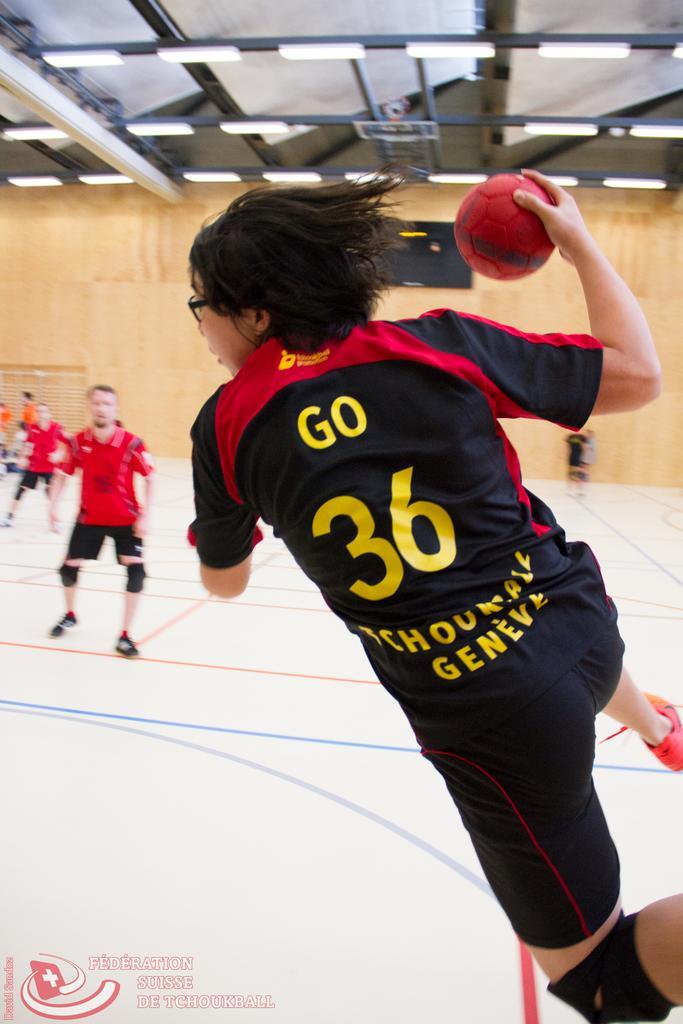Please provide a concise description of this image. In this image I can see a person holding a ball visible on the right side, in the middle I can see there are few persons visible on floor, at the bottom there is a symbol and text,at the top there is the roof and lights attached to the roof. 